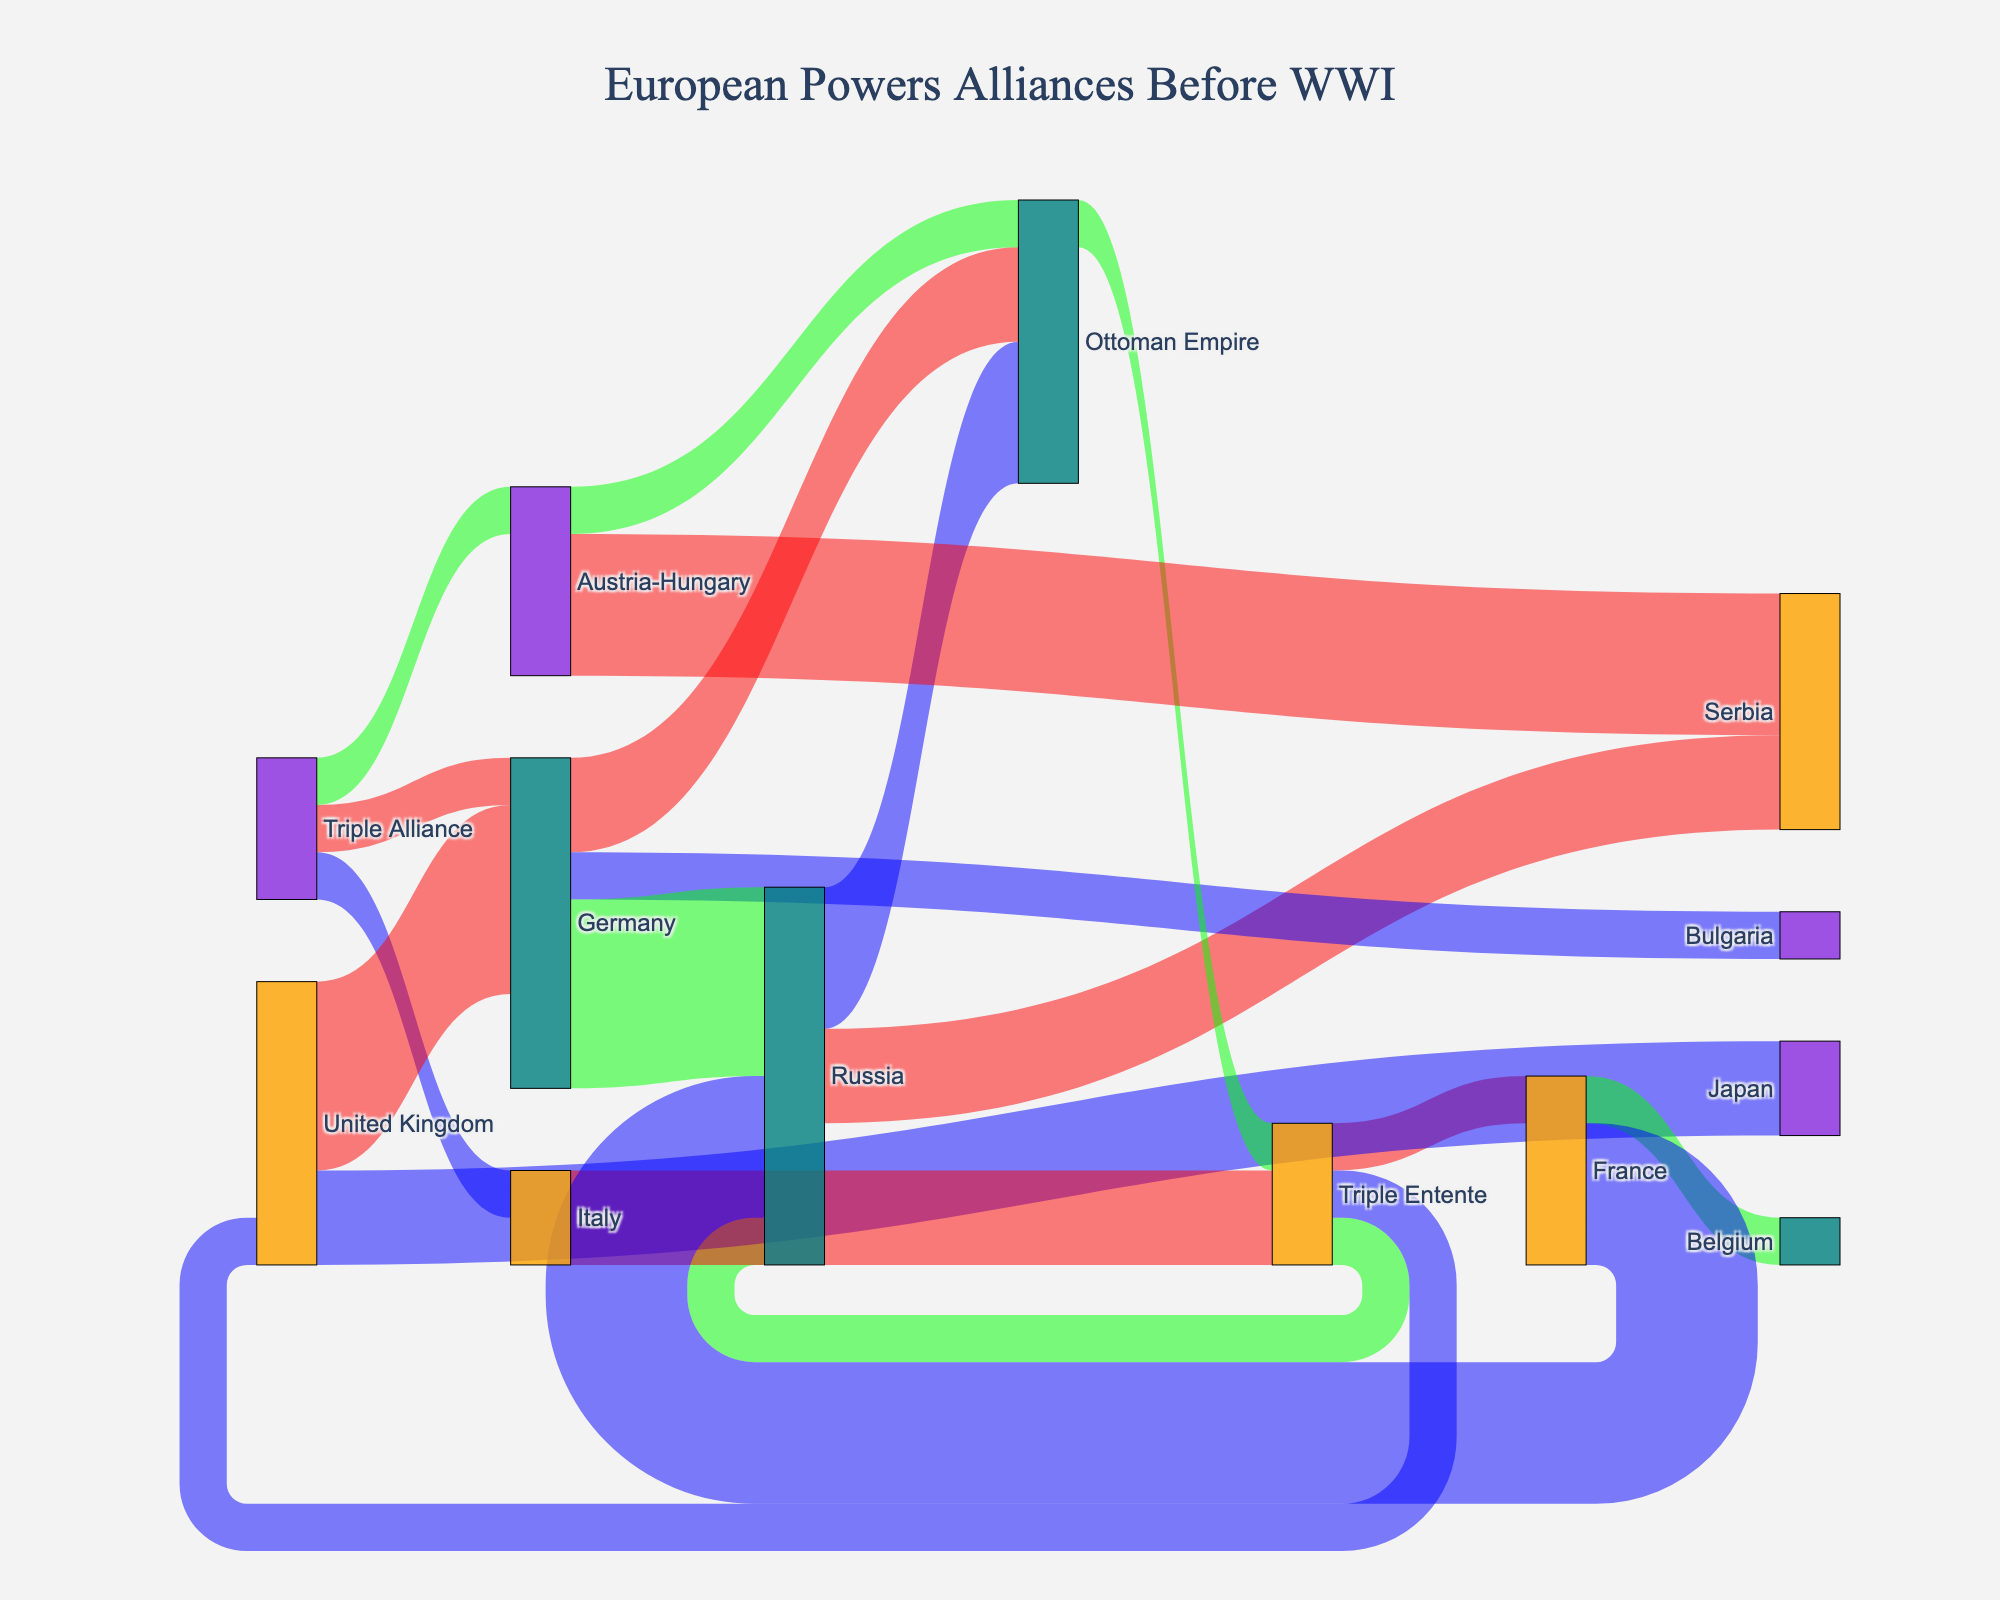Which alliance has a stronger connection with the Ottoman Empire, Germany or Russia? By examining the connections from the Ottoman Empire to Germany and Russia, we see two flows indicating connections. The connection from Germany to Ottoman Empire has a value of 2, whereas the connection from Russia to Ottoman Empire has a value of 3. This shows that Russia has a stronger connection with the Ottoman Empire.
Answer: Russia Which country has the most links with other countries? To determine this, we count the number of connections for each country. Germany has connections with the Triple Alliance, the Ottoman Empire, Bulgaria, Russia, and the United Kingdom, totaling 5 connections, which is the highest.
Answer: Germany How many countries or alliances are linked to both the Ottoman Empire and Serbia? We see connections involving the Ottoman Empire and Serbia: Austria-Hungary, Germany, and Russia are linked to both the Ottoman Empire and Serbia.
Answer: Three Which country switched alliances, and what was the value of that shift? By checking the diagram, we notice Italy switched from the Triple Alliance to the Triple Entente with a value of 2.
Answer: Italy, 2 How many countries are directly connected to the Triple Entente? The Triple Entente includes France, Russia, and the United Kingdom. Besides those forming the alliance, other countries connected to it are Italy and the Ottoman Empire. Therefore, the total number of countries directly connected to the Triple Entente is 5.
Answer: Five What is the total value of the connections from Germany? Identifying the connections from Germany, we see links to the Triple Alliance (1), the Ottoman Empire (2), Russia (4), Bulgaria (1), and the United Kingdom (4). Summing these values gives us 12.
Answer: 12 Which two countries have the highest connection value between them and what is the value? Looking at the link values, Germany and Russia have the highest connection value with a value of 4.
Answer: Germany and Russia, 4 What is the combined value of connections involving Austria-Hungary? Austria-Hungary has connections to the Triple Alliance (1), the Ottoman Empire (1), and Serbia (3), resulting in a total connection value of 5.
Answer: 5 How many flows are there between countries and alliances? To determine this, count the number of rows in the data, each representing a flow. There are 16 flows in total.
Answer: 16 